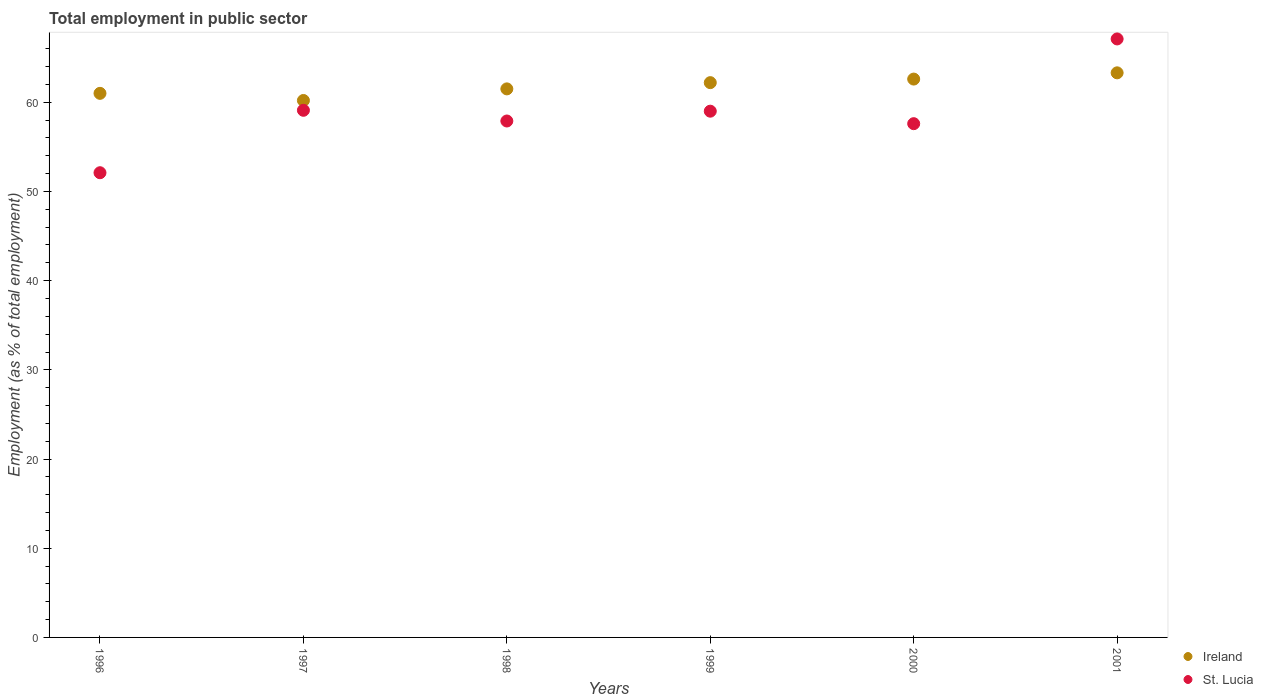How many different coloured dotlines are there?
Ensure brevity in your answer.  2. Is the number of dotlines equal to the number of legend labels?
Your response must be concise. Yes. What is the employment in public sector in Ireland in 2001?
Give a very brief answer. 63.3. Across all years, what is the maximum employment in public sector in Ireland?
Offer a very short reply. 63.3. Across all years, what is the minimum employment in public sector in St. Lucia?
Your answer should be compact. 52.1. In which year was the employment in public sector in St. Lucia maximum?
Your answer should be compact. 2001. What is the total employment in public sector in Ireland in the graph?
Your answer should be compact. 370.8. What is the difference between the employment in public sector in Ireland in 1998 and that in 1999?
Give a very brief answer. -0.7. What is the difference between the employment in public sector in St. Lucia in 1997 and the employment in public sector in Ireland in 1999?
Your response must be concise. -3.1. What is the average employment in public sector in Ireland per year?
Provide a succinct answer. 61.8. In the year 1996, what is the difference between the employment in public sector in St. Lucia and employment in public sector in Ireland?
Make the answer very short. -8.9. What is the ratio of the employment in public sector in Ireland in 1996 to that in 2001?
Give a very brief answer. 0.96. Is the employment in public sector in Ireland in 1998 less than that in 2000?
Provide a succinct answer. Yes. Is the difference between the employment in public sector in St. Lucia in 1996 and 1999 greater than the difference between the employment in public sector in Ireland in 1996 and 1999?
Provide a short and direct response. No. What is the difference between the highest and the second highest employment in public sector in Ireland?
Offer a very short reply. 0.7. What is the difference between the highest and the lowest employment in public sector in St. Lucia?
Your answer should be very brief. 15. In how many years, is the employment in public sector in St. Lucia greater than the average employment in public sector in St. Lucia taken over all years?
Keep it short and to the point. 3. Does the employment in public sector in Ireland monotonically increase over the years?
Your answer should be compact. No. Is the employment in public sector in Ireland strictly greater than the employment in public sector in St. Lucia over the years?
Offer a terse response. No. How many dotlines are there?
Make the answer very short. 2. How many years are there in the graph?
Your answer should be very brief. 6. What is the difference between two consecutive major ticks on the Y-axis?
Your response must be concise. 10. Are the values on the major ticks of Y-axis written in scientific E-notation?
Provide a short and direct response. No. Does the graph contain grids?
Offer a very short reply. No. How many legend labels are there?
Your response must be concise. 2. What is the title of the graph?
Provide a short and direct response. Total employment in public sector. Does "Vanuatu" appear as one of the legend labels in the graph?
Ensure brevity in your answer.  No. What is the label or title of the X-axis?
Offer a terse response. Years. What is the label or title of the Y-axis?
Your response must be concise. Employment (as % of total employment). What is the Employment (as % of total employment) of St. Lucia in 1996?
Your answer should be very brief. 52.1. What is the Employment (as % of total employment) of Ireland in 1997?
Provide a succinct answer. 60.2. What is the Employment (as % of total employment) in St. Lucia in 1997?
Make the answer very short. 59.1. What is the Employment (as % of total employment) in Ireland in 1998?
Offer a terse response. 61.5. What is the Employment (as % of total employment) of St. Lucia in 1998?
Provide a succinct answer. 57.9. What is the Employment (as % of total employment) in Ireland in 1999?
Give a very brief answer. 62.2. What is the Employment (as % of total employment) in Ireland in 2000?
Offer a terse response. 62.6. What is the Employment (as % of total employment) of St. Lucia in 2000?
Make the answer very short. 57.6. What is the Employment (as % of total employment) of Ireland in 2001?
Provide a short and direct response. 63.3. What is the Employment (as % of total employment) in St. Lucia in 2001?
Provide a succinct answer. 67.1. Across all years, what is the maximum Employment (as % of total employment) in Ireland?
Offer a very short reply. 63.3. Across all years, what is the maximum Employment (as % of total employment) in St. Lucia?
Offer a very short reply. 67.1. Across all years, what is the minimum Employment (as % of total employment) in Ireland?
Make the answer very short. 60.2. Across all years, what is the minimum Employment (as % of total employment) in St. Lucia?
Offer a very short reply. 52.1. What is the total Employment (as % of total employment) of Ireland in the graph?
Your answer should be compact. 370.8. What is the total Employment (as % of total employment) of St. Lucia in the graph?
Your response must be concise. 352.8. What is the difference between the Employment (as % of total employment) in Ireland in 1996 and that in 1998?
Keep it short and to the point. -0.5. What is the difference between the Employment (as % of total employment) in St. Lucia in 1996 and that in 1998?
Ensure brevity in your answer.  -5.8. What is the difference between the Employment (as % of total employment) of Ireland in 1996 and that in 1999?
Your response must be concise. -1.2. What is the difference between the Employment (as % of total employment) in St. Lucia in 1996 and that in 1999?
Provide a short and direct response. -6.9. What is the difference between the Employment (as % of total employment) in Ireland in 1996 and that in 2000?
Provide a succinct answer. -1.6. What is the difference between the Employment (as % of total employment) of St. Lucia in 1996 and that in 2000?
Ensure brevity in your answer.  -5.5. What is the difference between the Employment (as % of total employment) of St. Lucia in 1997 and that in 1998?
Your response must be concise. 1.2. What is the difference between the Employment (as % of total employment) of Ireland in 1997 and that in 1999?
Give a very brief answer. -2. What is the difference between the Employment (as % of total employment) of Ireland in 1997 and that in 2000?
Your response must be concise. -2.4. What is the difference between the Employment (as % of total employment) of Ireland in 1997 and that in 2001?
Your answer should be very brief. -3.1. What is the difference between the Employment (as % of total employment) in Ireland in 1998 and that in 2000?
Give a very brief answer. -1.1. What is the difference between the Employment (as % of total employment) of St. Lucia in 1998 and that in 2000?
Keep it short and to the point. 0.3. What is the difference between the Employment (as % of total employment) in Ireland in 1998 and that in 2001?
Your answer should be compact. -1.8. What is the difference between the Employment (as % of total employment) of St. Lucia in 1999 and that in 2000?
Provide a succinct answer. 1.4. What is the difference between the Employment (as % of total employment) of St. Lucia in 1999 and that in 2001?
Your response must be concise. -8.1. What is the difference between the Employment (as % of total employment) of Ireland in 2000 and that in 2001?
Your response must be concise. -0.7. What is the difference between the Employment (as % of total employment) in Ireland in 1996 and the Employment (as % of total employment) in St. Lucia in 1997?
Provide a succinct answer. 1.9. What is the difference between the Employment (as % of total employment) of Ireland in 1996 and the Employment (as % of total employment) of St. Lucia in 1998?
Your response must be concise. 3.1. What is the difference between the Employment (as % of total employment) of Ireland in 1996 and the Employment (as % of total employment) of St. Lucia in 2000?
Your response must be concise. 3.4. What is the difference between the Employment (as % of total employment) in Ireland in 1997 and the Employment (as % of total employment) in St. Lucia in 1999?
Make the answer very short. 1.2. What is the difference between the Employment (as % of total employment) in Ireland in 1997 and the Employment (as % of total employment) in St. Lucia in 2000?
Offer a very short reply. 2.6. What is the difference between the Employment (as % of total employment) of Ireland in 1998 and the Employment (as % of total employment) of St. Lucia in 1999?
Make the answer very short. 2.5. What is the difference between the Employment (as % of total employment) of Ireland in 1998 and the Employment (as % of total employment) of St. Lucia in 2001?
Offer a very short reply. -5.6. What is the difference between the Employment (as % of total employment) of Ireland in 1999 and the Employment (as % of total employment) of St. Lucia in 2001?
Your answer should be compact. -4.9. What is the difference between the Employment (as % of total employment) of Ireland in 2000 and the Employment (as % of total employment) of St. Lucia in 2001?
Your answer should be very brief. -4.5. What is the average Employment (as % of total employment) of Ireland per year?
Keep it short and to the point. 61.8. What is the average Employment (as % of total employment) in St. Lucia per year?
Offer a terse response. 58.8. In the year 1997, what is the difference between the Employment (as % of total employment) in Ireland and Employment (as % of total employment) in St. Lucia?
Offer a terse response. 1.1. In the year 1998, what is the difference between the Employment (as % of total employment) of Ireland and Employment (as % of total employment) of St. Lucia?
Make the answer very short. 3.6. In the year 2001, what is the difference between the Employment (as % of total employment) of Ireland and Employment (as % of total employment) of St. Lucia?
Ensure brevity in your answer.  -3.8. What is the ratio of the Employment (as % of total employment) in Ireland in 1996 to that in 1997?
Provide a short and direct response. 1.01. What is the ratio of the Employment (as % of total employment) in St. Lucia in 1996 to that in 1997?
Make the answer very short. 0.88. What is the ratio of the Employment (as % of total employment) in Ireland in 1996 to that in 1998?
Offer a terse response. 0.99. What is the ratio of the Employment (as % of total employment) in St. Lucia in 1996 to that in 1998?
Your answer should be compact. 0.9. What is the ratio of the Employment (as % of total employment) in Ireland in 1996 to that in 1999?
Ensure brevity in your answer.  0.98. What is the ratio of the Employment (as % of total employment) in St. Lucia in 1996 to that in 1999?
Your response must be concise. 0.88. What is the ratio of the Employment (as % of total employment) of Ireland in 1996 to that in 2000?
Make the answer very short. 0.97. What is the ratio of the Employment (as % of total employment) of St. Lucia in 1996 to that in 2000?
Your answer should be very brief. 0.9. What is the ratio of the Employment (as % of total employment) of Ireland in 1996 to that in 2001?
Your answer should be compact. 0.96. What is the ratio of the Employment (as % of total employment) of St. Lucia in 1996 to that in 2001?
Your response must be concise. 0.78. What is the ratio of the Employment (as % of total employment) of Ireland in 1997 to that in 1998?
Provide a succinct answer. 0.98. What is the ratio of the Employment (as % of total employment) in St. Lucia in 1997 to that in 1998?
Offer a very short reply. 1.02. What is the ratio of the Employment (as % of total employment) of Ireland in 1997 to that in 1999?
Keep it short and to the point. 0.97. What is the ratio of the Employment (as % of total employment) in St. Lucia in 1997 to that in 1999?
Offer a very short reply. 1. What is the ratio of the Employment (as % of total employment) in Ireland in 1997 to that in 2000?
Your answer should be very brief. 0.96. What is the ratio of the Employment (as % of total employment) of St. Lucia in 1997 to that in 2000?
Make the answer very short. 1.03. What is the ratio of the Employment (as % of total employment) in Ireland in 1997 to that in 2001?
Keep it short and to the point. 0.95. What is the ratio of the Employment (as % of total employment) of St. Lucia in 1997 to that in 2001?
Make the answer very short. 0.88. What is the ratio of the Employment (as % of total employment) of Ireland in 1998 to that in 1999?
Your answer should be compact. 0.99. What is the ratio of the Employment (as % of total employment) of St. Lucia in 1998 to that in 1999?
Keep it short and to the point. 0.98. What is the ratio of the Employment (as % of total employment) in Ireland in 1998 to that in 2000?
Ensure brevity in your answer.  0.98. What is the ratio of the Employment (as % of total employment) of St. Lucia in 1998 to that in 2000?
Provide a short and direct response. 1.01. What is the ratio of the Employment (as % of total employment) of Ireland in 1998 to that in 2001?
Ensure brevity in your answer.  0.97. What is the ratio of the Employment (as % of total employment) in St. Lucia in 1998 to that in 2001?
Your answer should be compact. 0.86. What is the ratio of the Employment (as % of total employment) in Ireland in 1999 to that in 2000?
Your answer should be compact. 0.99. What is the ratio of the Employment (as % of total employment) in St. Lucia in 1999 to that in 2000?
Make the answer very short. 1.02. What is the ratio of the Employment (as % of total employment) in Ireland in 1999 to that in 2001?
Ensure brevity in your answer.  0.98. What is the ratio of the Employment (as % of total employment) of St. Lucia in 1999 to that in 2001?
Your answer should be very brief. 0.88. What is the ratio of the Employment (as % of total employment) in Ireland in 2000 to that in 2001?
Provide a short and direct response. 0.99. What is the ratio of the Employment (as % of total employment) of St. Lucia in 2000 to that in 2001?
Your answer should be very brief. 0.86. What is the difference between the highest and the second highest Employment (as % of total employment) in Ireland?
Your answer should be compact. 0.7. 